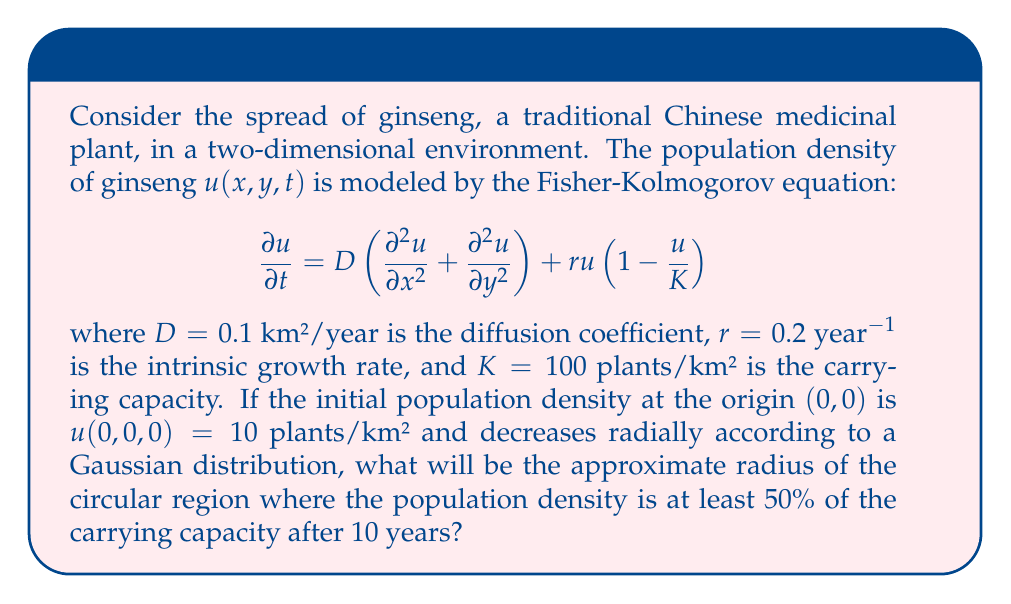Provide a solution to this math problem. To solve this problem, we need to understand the behavior of the Fisher-Kolmogorov equation and use the concept of traveling wave solutions. Here's a step-by-step approach:

1) The Fisher-Kolmogorov equation describes a reaction-diffusion system with logistic growth. For radially symmetric solutions, it can be approximated by a traveling wave with speed $c$.

2) The minimum wave speed for the Fisher-Kolmogorov equation is given by:

   $$c = 2\sqrt{Dr}$$

3) Substituting the given values:

   $$c = 2\sqrt{0.1 \cdot 0.2} = 2\sqrt{0.02} \approx 0.283$$ km/year

4) After 10 years, the wave front will have traveled approximately:

   $$\text{Distance} = c \cdot t = 0.283 \cdot 10 \approx 2.83$$ km

5) Behind the wave front, the population approaches the carrying capacity $K$. We're interested in the region where $u \geq 0.5K = 50$ plants/km².

6) The transition from low to high density in the traveling wave solution occurs over a characteristic width. A good approximation is that the region where $u \geq 0.5K$ extends about 1 km behind the wave front.

7) Therefore, the radius of the circular region where $u \geq 0.5K$ after 10 years is approximately:

   $$\text{Radius} \approx 2.83 - 1 = 1.83$$ km

This result reflects the cultural significance of ginseng in traditional Chinese medicine, showing how such valuable plants might spread in a new environment, reminiscent of the spread of cultural practices in immigrant communities as studied by pioneers like Fay Chew Matsuda.
Answer: The approximate radius of the circular region where the ginseng population density is at least 50% of the carrying capacity after 10 years is 1.83 km. 